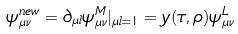<formula> <loc_0><loc_0><loc_500><loc_500>\psi ^ { n e w } _ { \mu \nu } = \partial _ { \mu l } \psi ^ { M } _ { \mu \nu } | _ { \mu l = 1 } = y ( \tau , \rho ) \psi ^ { L } _ { \mu \nu }</formula> 